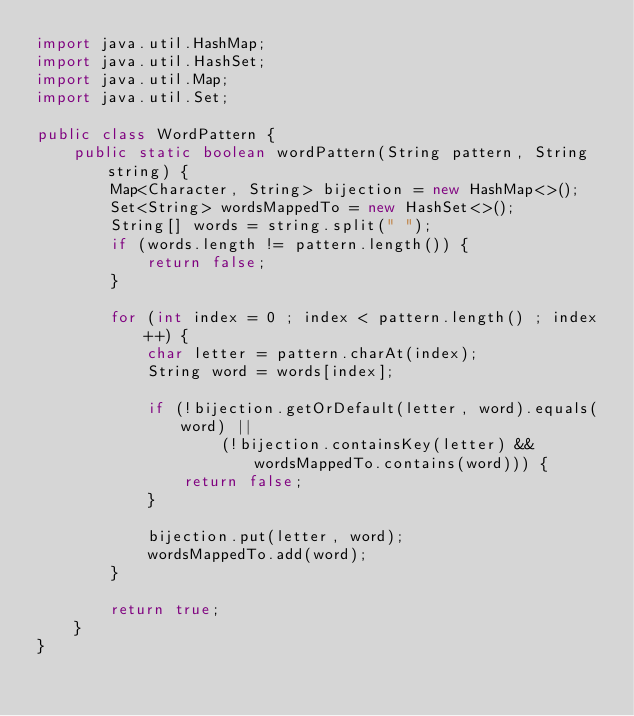<code> <loc_0><loc_0><loc_500><loc_500><_Java_>import java.util.HashMap;
import java.util.HashSet;
import java.util.Map;
import java.util.Set;

public class WordPattern {
    public static boolean wordPattern(String pattern, String string) {
        Map<Character, String> bijection = new HashMap<>();
        Set<String> wordsMappedTo = new HashSet<>();
        String[] words = string.split(" ");
        if (words.length != pattern.length()) {
            return false;
        }

        for (int index = 0 ; index < pattern.length() ; index++) {
            char letter = pattern.charAt(index);
            String word = words[index];

            if (!bijection.getOrDefault(letter, word).equals(word) ||
                    (!bijection.containsKey(letter) && wordsMappedTo.contains(word))) {
                return false;
            }

            bijection.put(letter, word);
            wordsMappedTo.add(word);
        }

        return true;
    }
}
</code> 